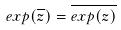<formula> <loc_0><loc_0><loc_500><loc_500>e x p ( \overline { z } ) = \overline { e x p ( z ) }</formula> 